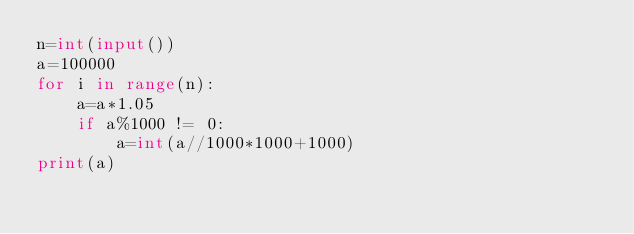<code> <loc_0><loc_0><loc_500><loc_500><_Python_>n=int(input())
a=100000
for i in range(n):
    a=a*1.05
    if a%1000 != 0:
        a=int(a//1000*1000+1000)
print(a)


</code> 